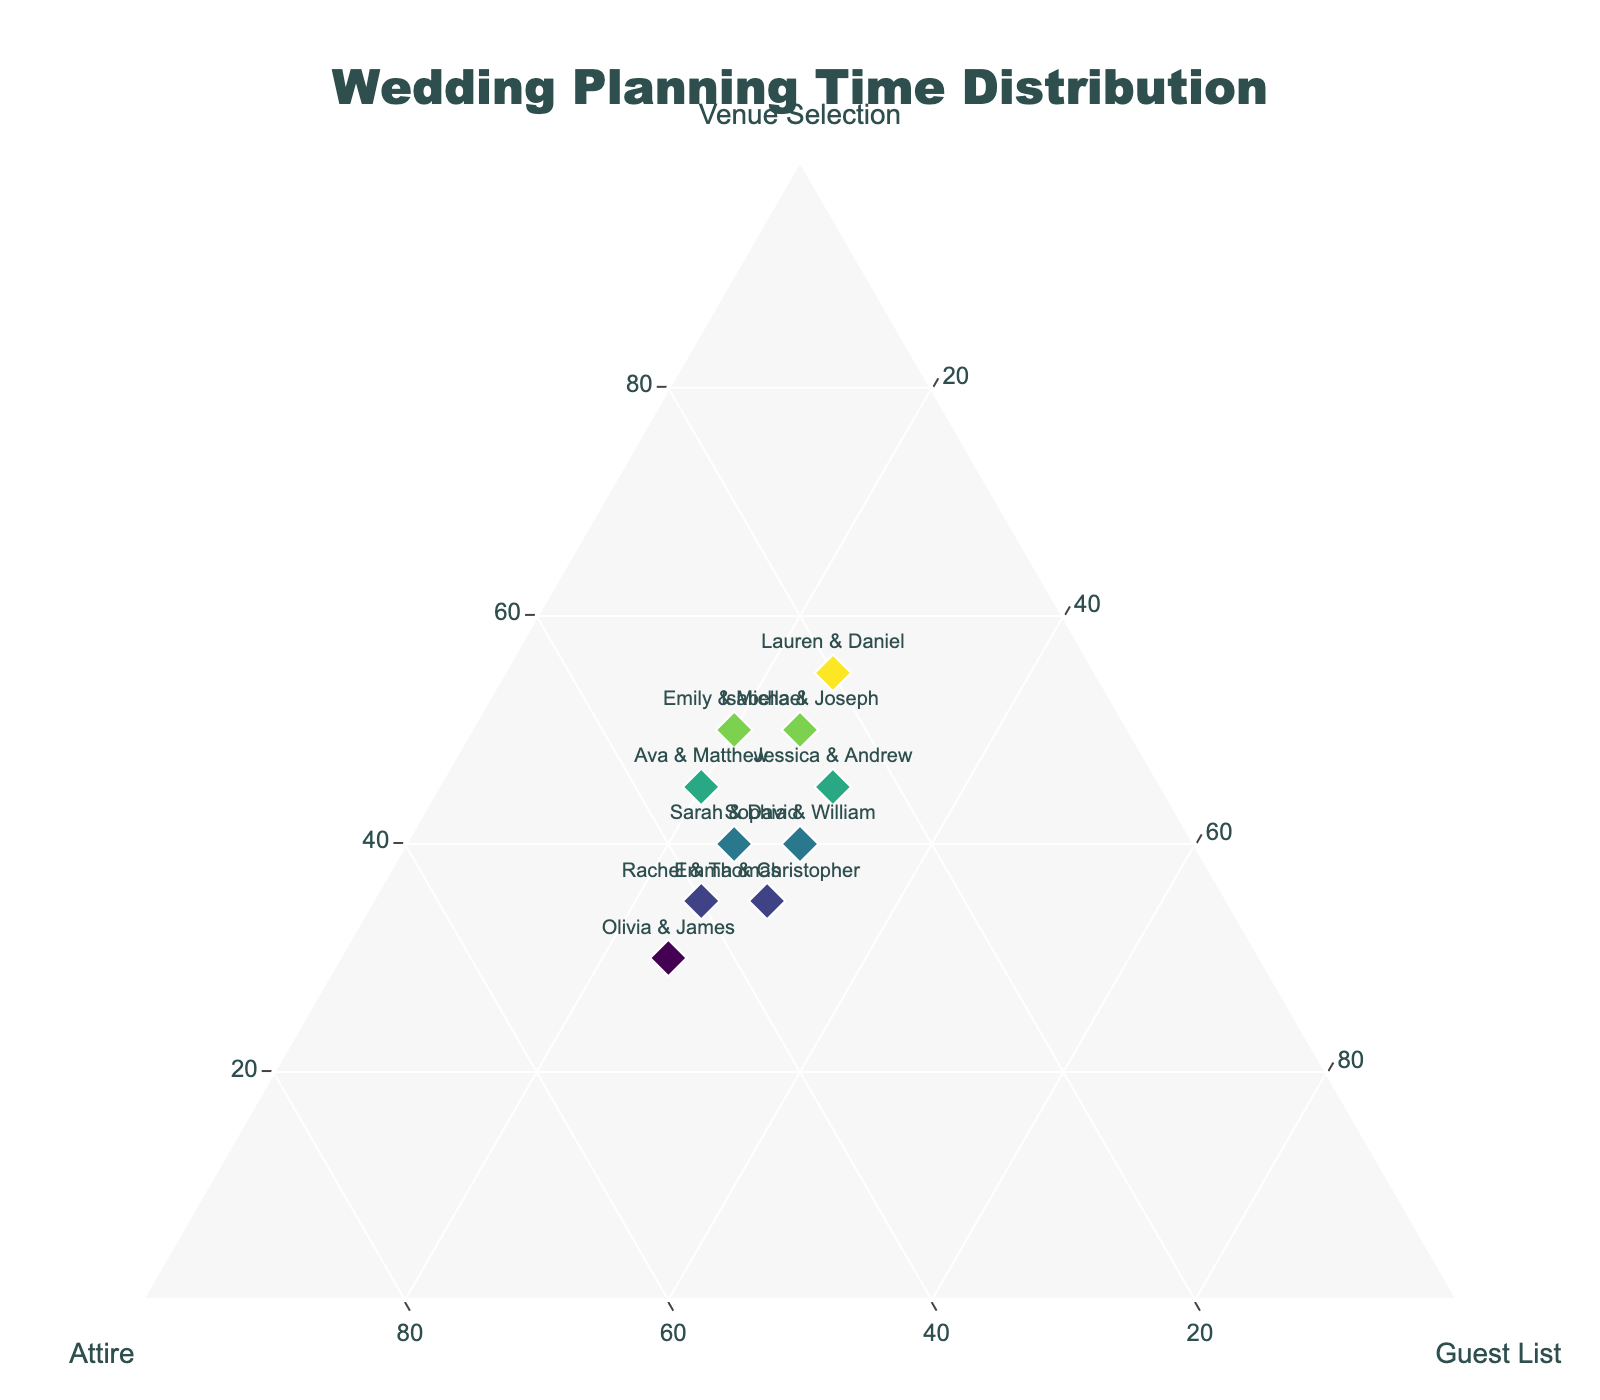What is the title of the ternary plot? The title is located at the top center of the figure and is clearly visible.
Answer: Wedding Planning Time Distribution Which couple spent the least time on venue selection? By looking at the 'Venue Selection' axis (labeled 'a') and observing the points closer to the 'Attire' axis, we see that Olivia & James spent only 30% on venue selection, which is the least among all couples.
Answer: Olivia & James Which axis represents the time spent on attire? The axis titles are present around the ternary plot. The 'Attire' axis is labeled 'b'.
Answer: b axis What is the sum of the percentages for venue selection, attire, and guest list for each couple? In a ternary plot, each data point represents a distribution that sums to 100%. Hence, the sum for each couple is 100%.
Answer: 100% Who spent the most time on attire, and how much was it? By looking at who is closest to the 'Attire' axis, we determine that Olivia & James spent the most time on attire, which is 45%.
Answer: Olivia & James, 45% Compare the time spent by Jessica & Andrew on venue selection and guest list. Which one is higher? From Jessica & Andrew’s data point positioned against the axes, we see they spent 45% on venue selection and 30% on guest list, so venue selection is higher.
Answer: Venue selection Which two couples spent an equal amount of time on the guest list? Observing the locations relative to the 'Guest List' axis, both Olivia & James and Lauren & Daniel spent 25% on the guest list.
Answer: Olivia & James and Lauren & Daniel What percentage of time did Rachel & Thomas spend on attire compared to Sophia & William? Rachel & Thomas spent 40% on attire while Sophia & William spent 30%. Therefore, Rachel & Thomas spent 10% more on attire compared to Sophia & William.
Answer: Rachel & Thomas spent 10% more How many couples spent more time on venue selection than on guest list? Comparing the 'Venue Selection' percentages with the 'Guest List' percentages, we see that 7 couples (Emily & Michael, Sarah & David, Jessica & Andrew, Rachel & Thomas, Lauren & Daniel, Ava & Matthew, Isabella & Joseph) spent more on venue selection.
Answer: 7 couples What is the average time spent on attire by all couples? Adding up the percentages for attire: 30 + 35 + 25 + 40 + 20 + 45 + 30 + 35 + 35 + 25 = 320, then dividing by the number of couples, 320 / 10 = 32%.
Answer: 32% 